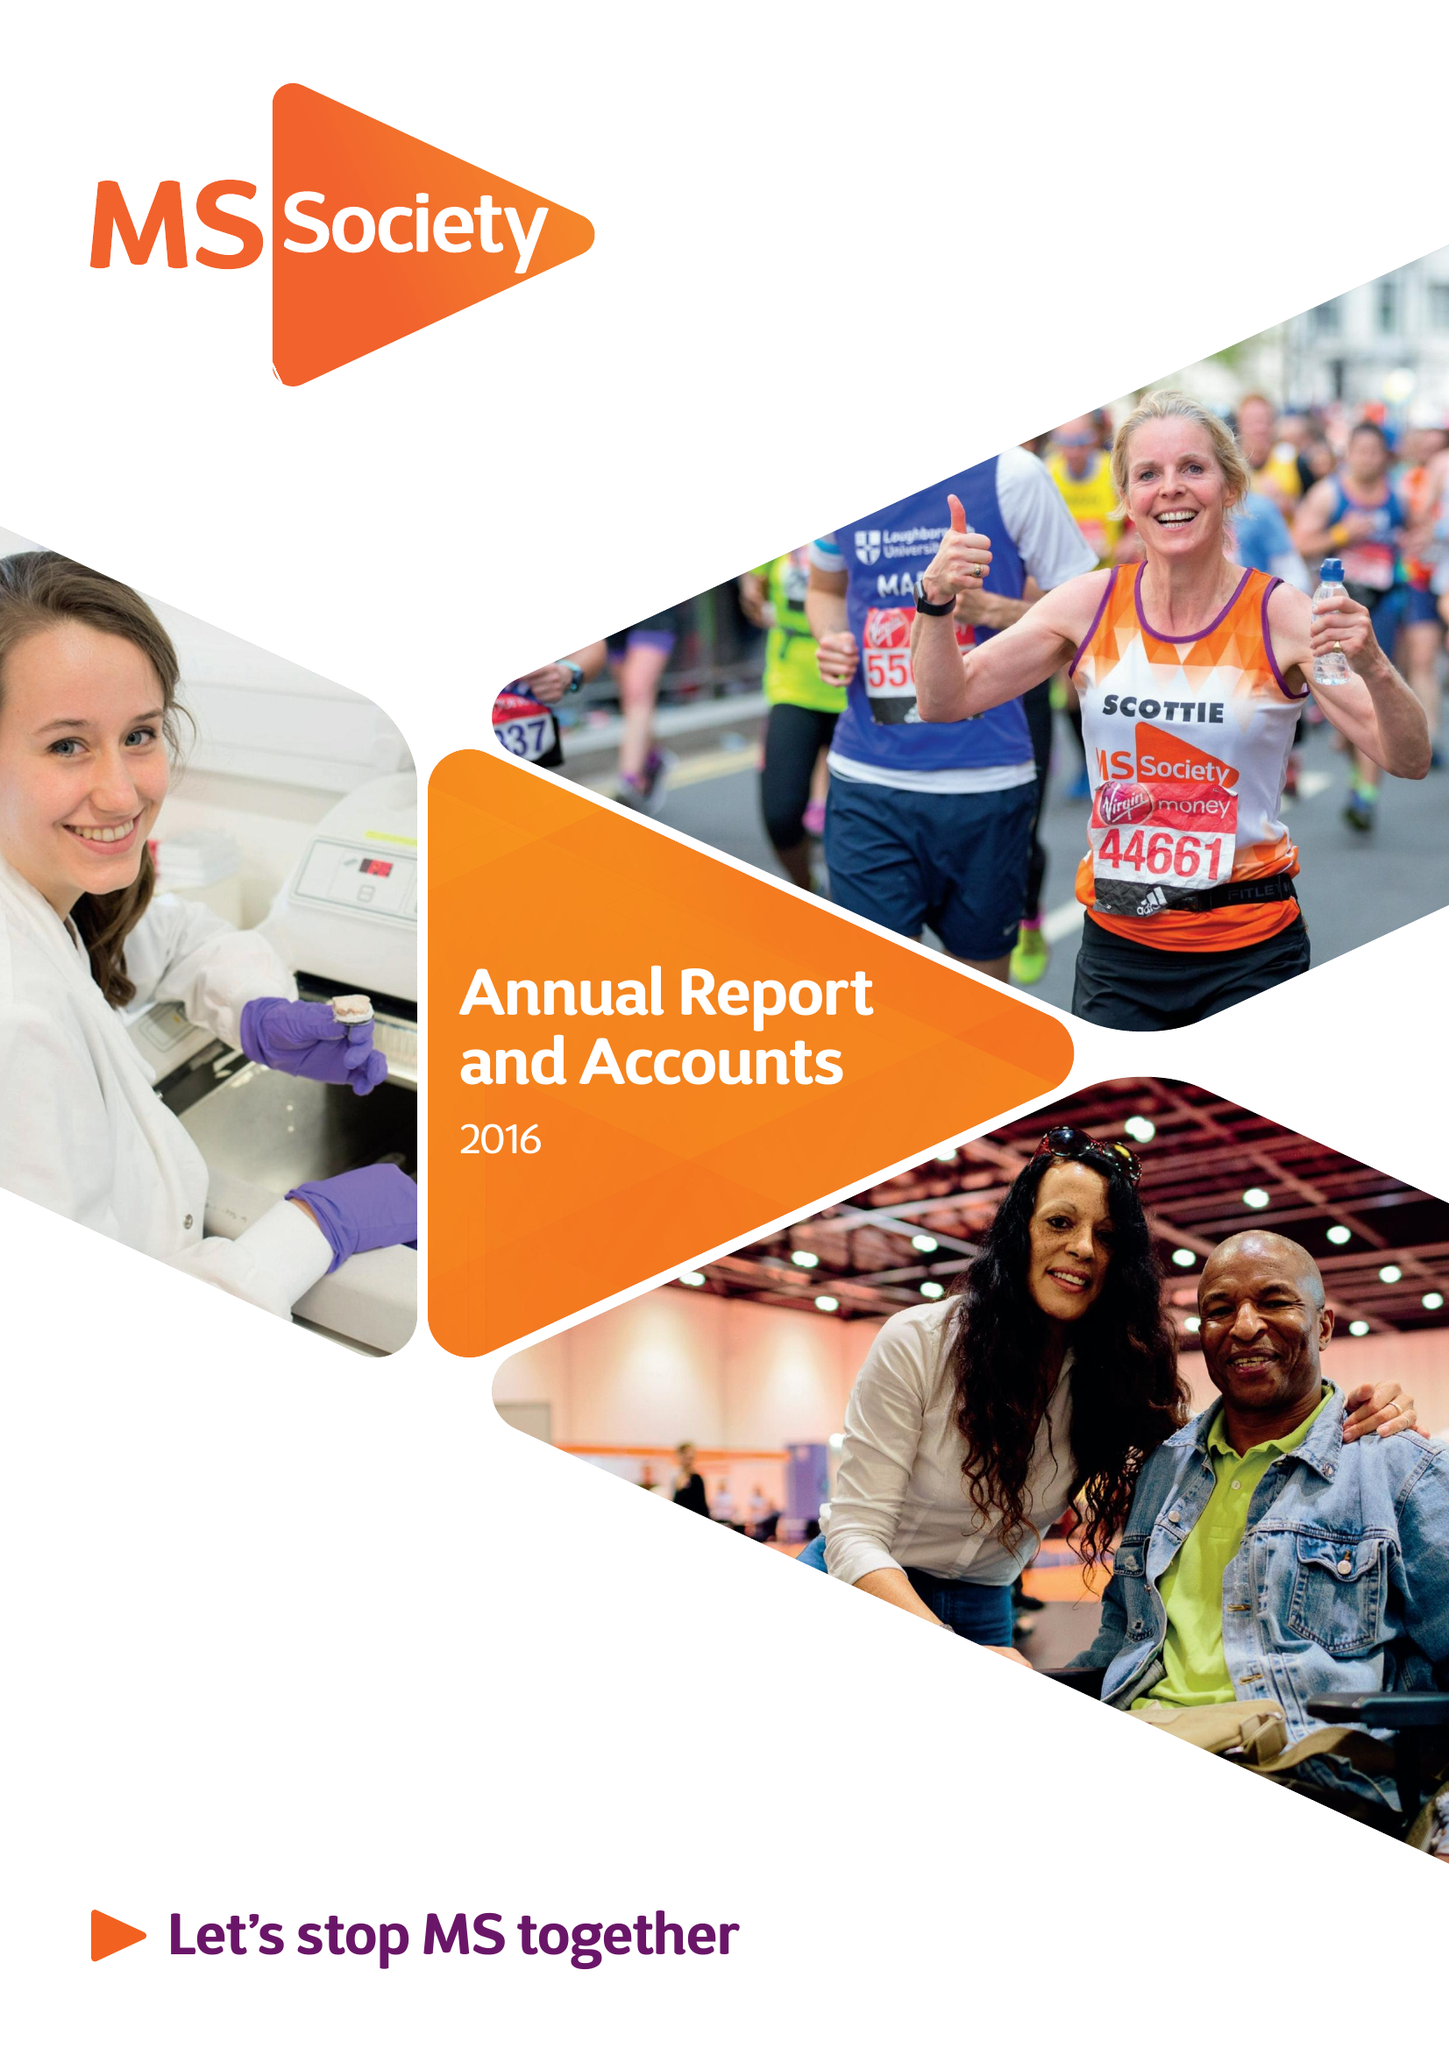What is the value for the address__street_line?
Answer the question using a single word or phrase. 372 EDGWARE ROAD 